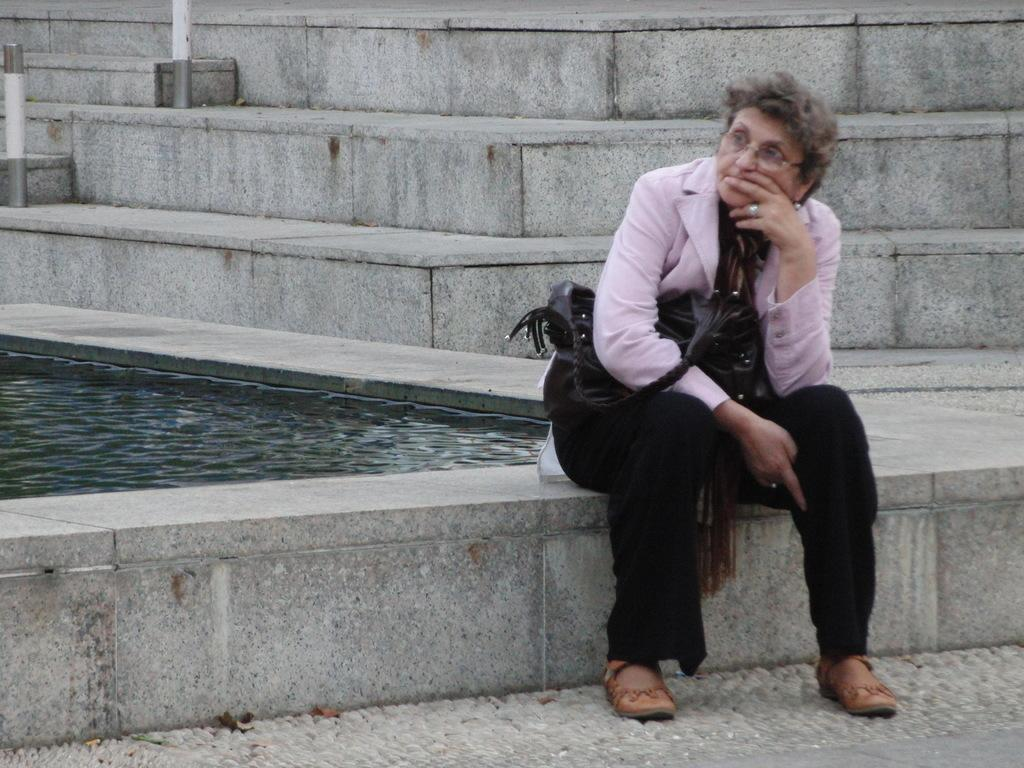What is the main subject of the image? There is a woman sitting in the front of the image. What is the woman doing in the image? The woman appears to be thinking. What can be seen behind the woman in the image? There is a small water pool behind the woman. What architectural feature is visible in the background of the image? There are steps visible in the background of the image. Can you see a monkey sitting on the bed in the image? There is no monkey or bed present in the image. What type of creature is joining the woman in the image? There is no creature present in the image; the woman is alone. 